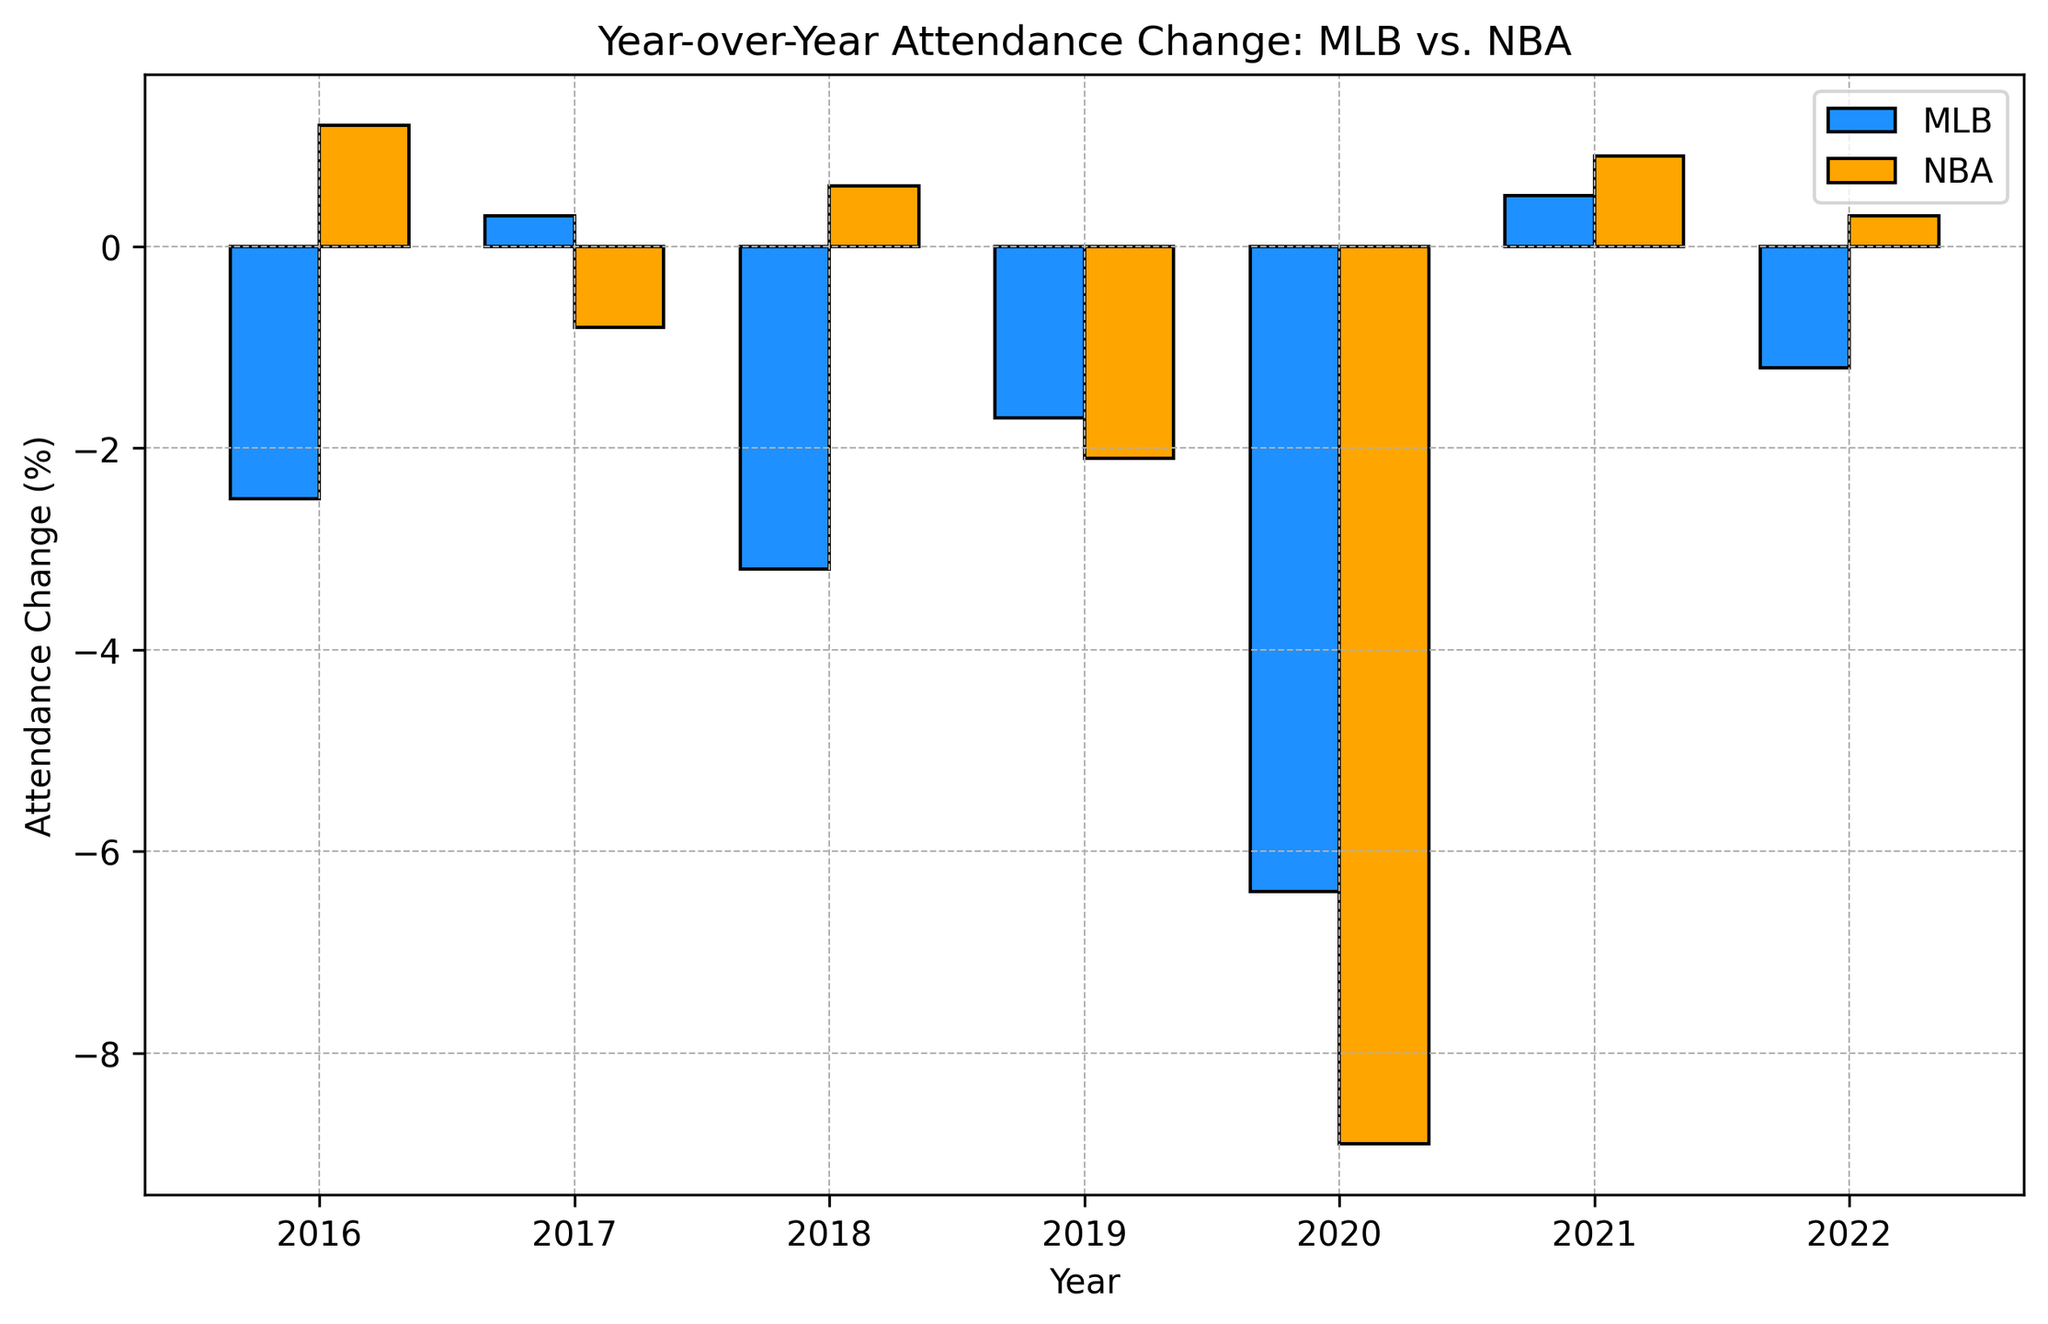What's the overall trend in MLB attendance change from 2016 to 2022? The MLB attendance change fluctuates, with notable drops in 2016, 2018, 2019, 2020, and 2022, and slight increases in 2017 and 2021.
Answer: Fluctuating trend with overall declines Which year shows the biggest contrast between MLB and NBA attendance changes? In 2020, MLB attendance change is -6.4% while NBA attendance change is -8.9%. The difference is 2.5 percentage points, the largest contrast compared to other years.
Answer: 2020 In what years did both MLB and NBA attendance changes decrease? Both leagues show a decrease in 2019 and 2020 where the MLB had -1.7% and -6.4% while NBA had -2.1% and -8.9%.
Answer: 2019 and 2020 What was the MLB attendance change in the year that had the worst NBA attendance drop? The worst NBA attendance drop was in 2020 with a -8.9% change. In the same year, the MLB attendance change was -6.4%.
Answer: -6.4% Which league had a higher average attendance change, and by how much? Calculate the averages: MLB: (-2.5 + 0.3 - 3.2 - 1.7 - 6.4 + 0.5 - 1.2) / 7 = -2.03%. NBA: (1.2 - 0.8 + 0.6 - 2.1 - 8.9 + 0.9 + 0.3) / 7 = -1.17%. The NBA had a higher average attendance change by 0.86%.
Answer: NBA by 0.86% In which years did the MLB attendance see an increase? The MLB attendance increased in 2017 by 0.3% and in 2021 by 0.5%.
Answer: 2017 and 2021 What year had the smallest drop in MLB attendance, and what was the drop percentage? The smallest drop in MLB attendance occurred in 2022 with a decrease of -1.2%.
Answer: 2022, -1.2% Which league has more years with positive attendance changes? The NBA has more years with positive attendance changes with 4 years (2016, 2018, 2021, 2022) compared to MLB's 2 years (2017, 2021).
Answer: NBA How does the height of the NBA bar in 2020 compare to the MLB bar for the same year? In 2020, the NBA bar is visually taller than the MLB bar. The NBA attendance change is -8.9%, much lower than the MLB's -6.4%, making the NBA bar longer downwards since negative values are represented by lower bars.
Answer: NBA bar is taller downward Calculate the total change in MLB attendance from 2016 to 2022. Summing all changes: -2.5% + 0.3% - 3.2% - 1.7% - 6.4% + 0.5% - 1.2% equals -14.2%.
Answer: -14.2% 